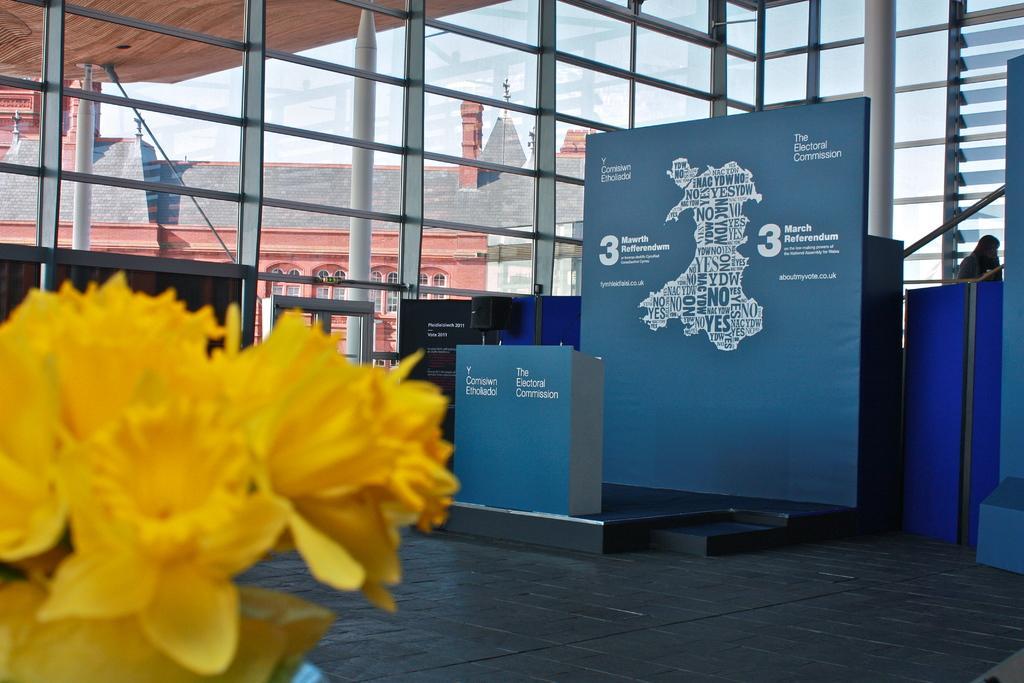Please provide a concise description of this image. In this image in front there are yellow flowers. On the backside there are two boards. Behind the boards, there is a metal fence. In the background there is a building and at the top there is the sky. 